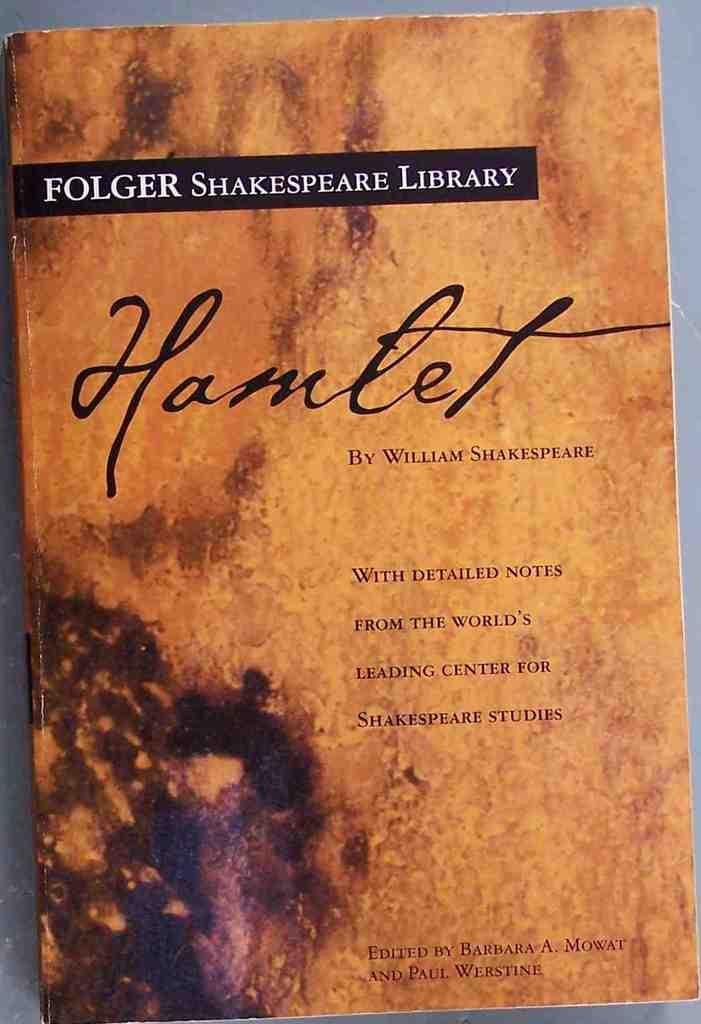<image>
Present a compact description of the photo's key features. A copy of Shakespeare's Hamlet has an orange cover. 